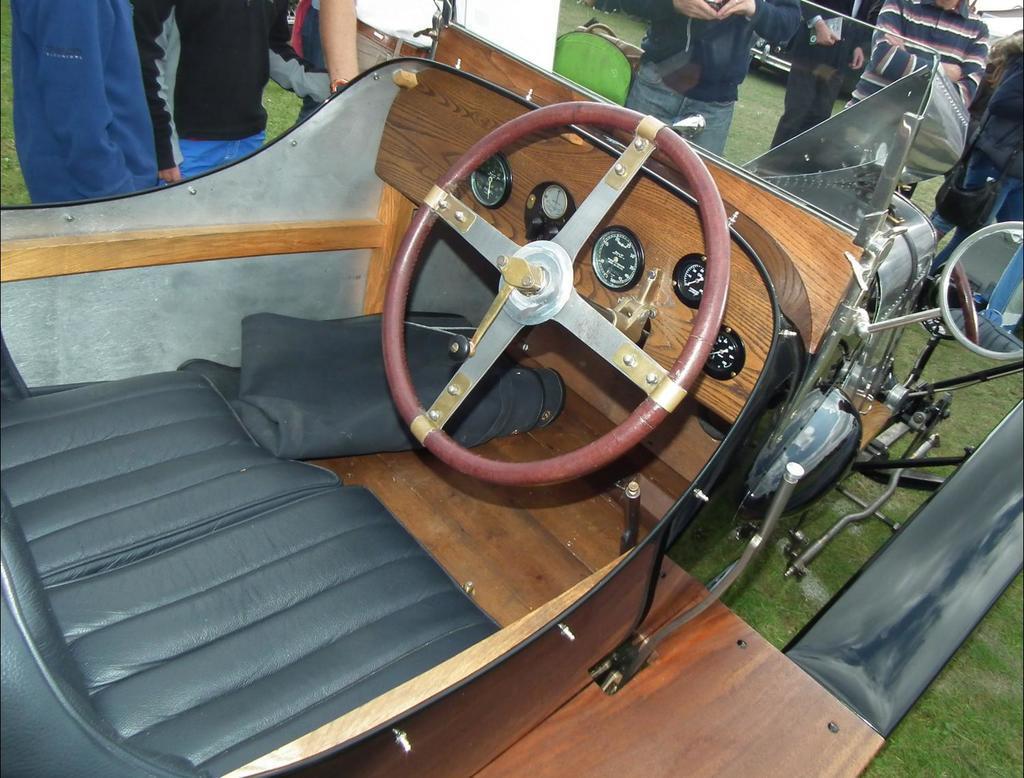Could you give a brief overview of what you see in this image? In the picture we can see a vintage car which is a very old model with steering, and some meters and a seat which is black in color and some people are standing around it on the grass surface. 